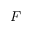Convert formula to latex. <formula><loc_0><loc_0><loc_500><loc_500>F</formula> 